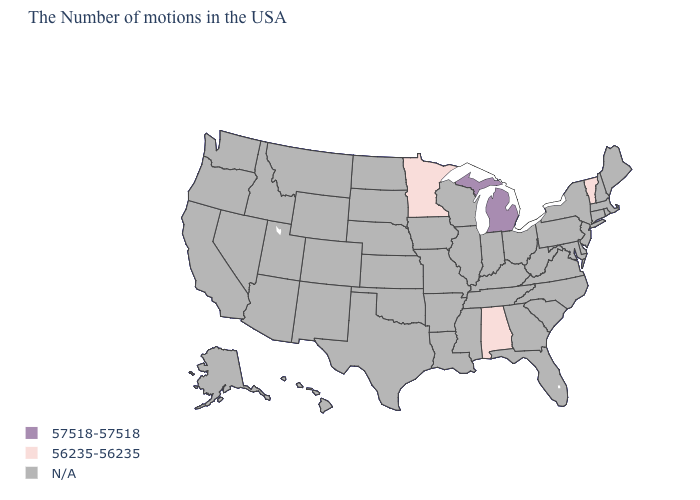Does Minnesota have the highest value in the USA?
Keep it brief. No. Is the legend a continuous bar?
Answer briefly. No. Name the states that have a value in the range 56235-56235?
Answer briefly. Vermont, Alabama, Minnesota. Name the states that have a value in the range 57518-57518?
Give a very brief answer. Michigan. Name the states that have a value in the range 57518-57518?
Keep it brief. Michigan. Name the states that have a value in the range 57518-57518?
Be succinct. Michigan. What is the highest value in the USA?
Be succinct. 57518-57518. What is the value of Connecticut?
Be succinct. N/A. Name the states that have a value in the range 57518-57518?
Short answer required. Michigan. Name the states that have a value in the range 56235-56235?
Answer briefly. Vermont, Alabama, Minnesota. Does Michigan have the highest value in the MidWest?
Concise answer only. Yes. Which states hav the highest value in the Northeast?
Give a very brief answer. Vermont. Which states have the lowest value in the South?
Concise answer only. Alabama. What is the value of Delaware?
Short answer required. N/A. 